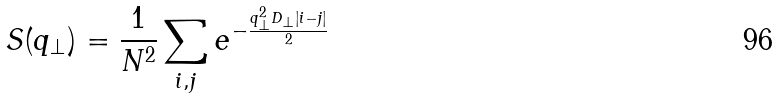Convert formula to latex. <formula><loc_0><loc_0><loc_500><loc_500>S ( q _ { \bot } ) = \frac { 1 } { N ^ { 2 } } \sum _ { i , j } e ^ { - \frac { q ^ { 2 } _ { \bot } D _ { \bot } | i - j | } { 2 } }</formula> 